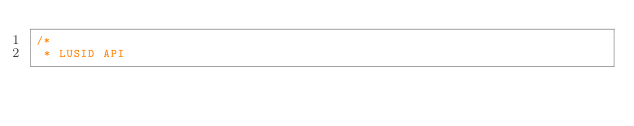Convert code to text. <code><loc_0><loc_0><loc_500><loc_500><_Java_>/*
 * LUSID API</code> 